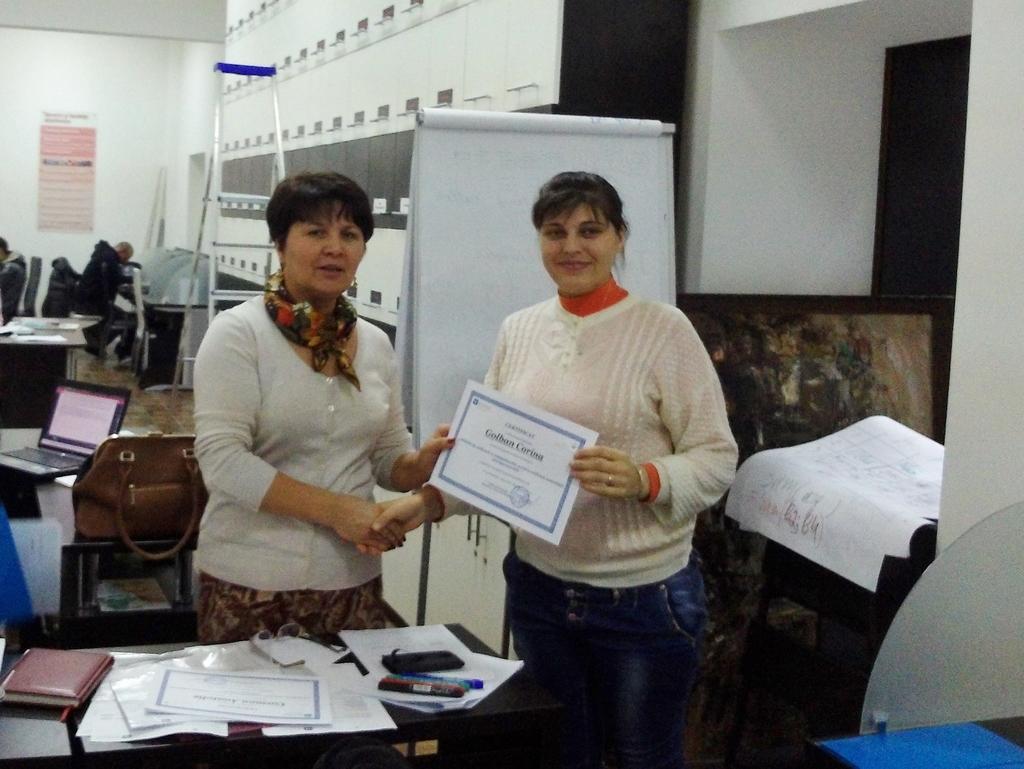Can you describe this image briefly? In this image there are two persons wearing white color sweaters a shaking their hands each other and showing a certificate to the camera and at the background of the image there is a wall and persons doing some work. 